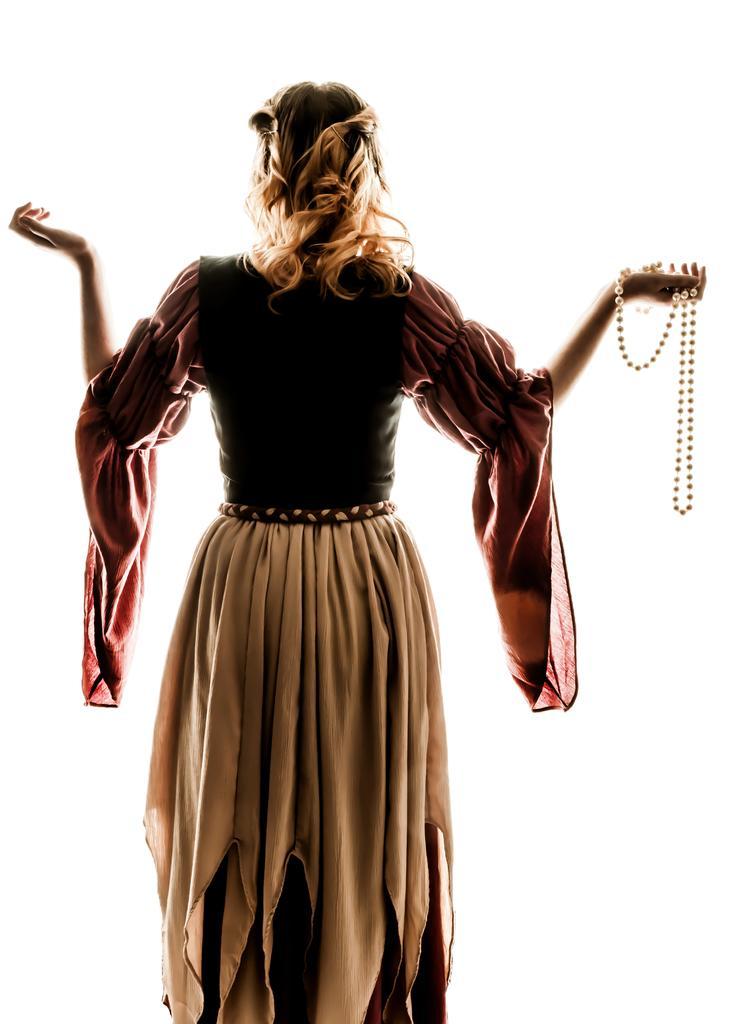Can you describe this image briefly? In this image we can see a lady holding chain. In the background there it is white. 